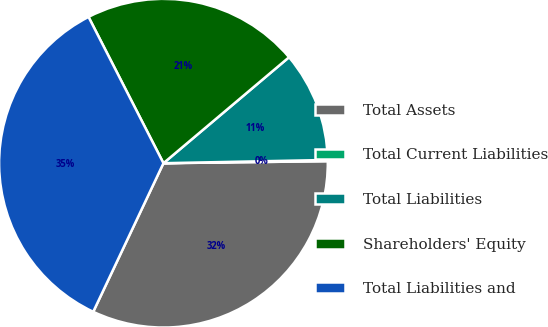<chart> <loc_0><loc_0><loc_500><loc_500><pie_chart><fcel>Total Assets<fcel>Total Current Liabilities<fcel>Total Liabilities<fcel>Shareholders' Equity<fcel>Total Liabilities and<nl><fcel>32.22%<fcel>0.12%<fcel>10.84%<fcel>21.38%<fcel>35.44%<nl></chart> 